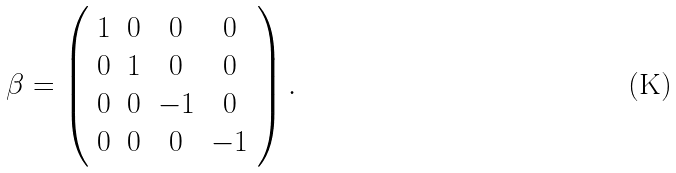<formula> <loc_0><loc_0><loc_500><loc_500>\beta = \left ( \begin{array} { c c c c } 1 & 0 & 0 & 0 \\ 0 & 1 & 0 & 0 \\ 0 & 0 & - 1 & 0 \\ 0 & 0 & 0 & - 1 \end{array} \right ) .</formula> 